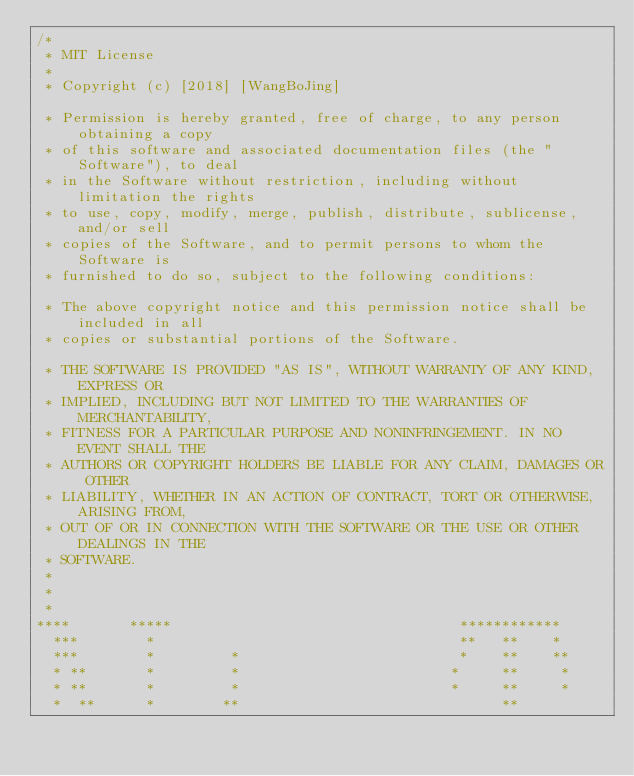Convert code to text. <code><loc_0><loc_0><loc_500><loc_500><_C_>/*
 * MIT License
 *
 * Copyright (c) [2018] [WangBoJing]

 * Permission is hereby granted, free of charge, to any person obtaining a copy
 * of this software and associated documentation files (the "Software"), to deal
 * in the Software without restriction, including without limitation the rights
 * to use, copy, modify, merge, publish, distribute, sublicense, and/or sell
 * copies of the Software, and to permit persons to whom the Software is
 * furnished to do so, subject to the following conditions:

 * The above copyright notice and this permission notice shall be included in all
 * copies or substantial portions of the Software.

 * THE SOFTWARE IS PROVIDED "AS IS", WITHOUT WARRANTY OF ANY KIND, EXPRESS OR
 * IMPLIED, INCLUDING BUT NOT LIMITED TO THE WARRANTIES OF MERCHANTABILITY,
 * FITNESS FOR A PARTICULAR PURPOSE AND NONINFRINGEMENT. IN NO EVENT SHALL THE
 * AUTHORS OR COPYRIGHT HOLDERS BE LIABLE FOR ANY CLAIM, DAMAGES OR OTHER
 * LIABILITY, WHETHER IN AN ACTION OF CONTRACT, TORT OR OTHERWISE, ARISING FROM,
 * OUT OF OR IN CONNECTION WITH THE SOFTWARE OR THE USE OR OTHER DEALINGS IN THE
 * SOFTWARE.
 *
 *
 *
****       *****                                  ************
  ***        *                                    **   **    *
  ***        *         *                          *    **    **
  * **       *         *                         *     **     *
  * **       *         *                         *     **     *
  *  **      *        **                               **</code> 